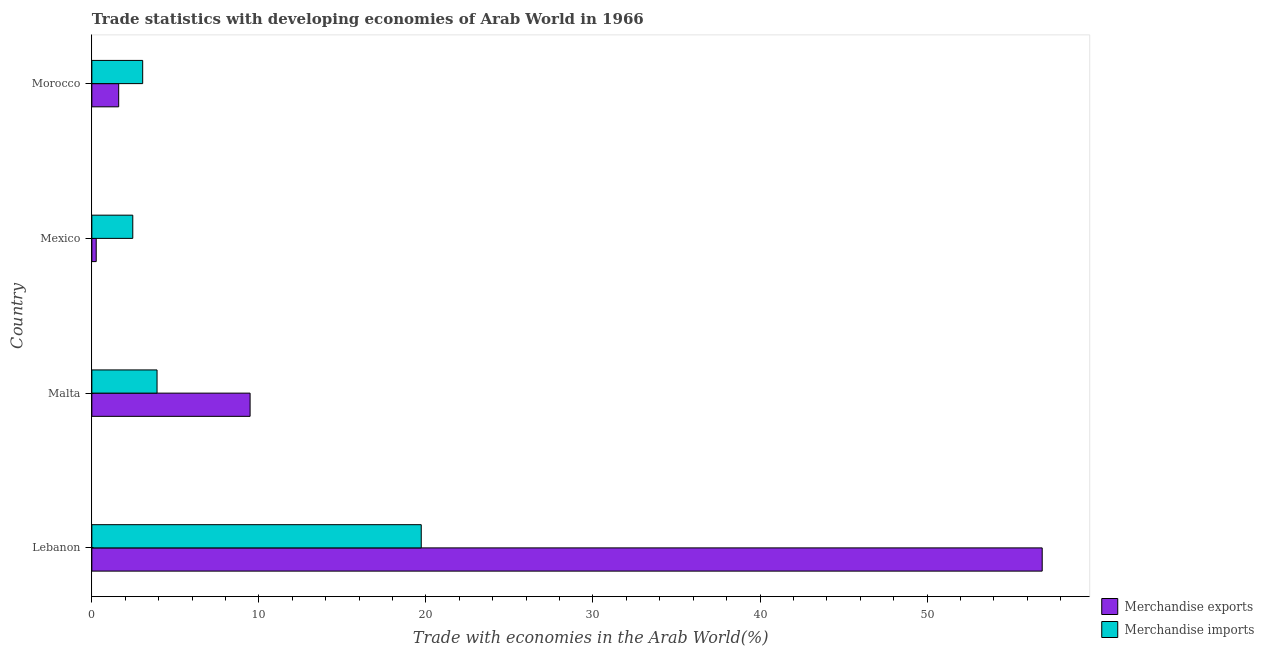How many different coloured bars are there?
Provide a succinct answer. 2. How many groups of bars are there?
Keep it short and to the point. 4. How many bars are there on the 3rd tick from the top?
Keep it short and to the point. 2. What is the label of the 4th group of bars from the top?
Keep it short and to the point. Lebanon. What is the merchandise exports in Lebanon?
Give a very brief answer. 56.89. Across all countries, what is the maximum merchandise exports?
Offer a very short reply. 56.89. Across all countries, what is the minimum merchandise exports?
Make the answer very short. 0.26. In which country was the merchandise exports maximum?
Give a very brief answer. Lebanon. In which country was the merchandise exports minimum?
Keep it short and to the point. Mexico. What is the total merchandise imports in the graph?
Your response must be concise. 29.12. What is the difference between the merchandise imports in Mexico and that in Morocco?
Your answer should be very brief. -0.59. What is the difference between the merchandise exports in Lebanon and the merchandise imports in Malta?
Keep it short and to the point. 52.99. What is the average merchandise imports per country?
Your response must be concise. 7.28. What is the difference between the merchandise imports and merchandise exports in Mexico?
Give a very brief answer. 2.19. What is the ratio of the merchandise imports in Lebanon to that in Mexico?
Offer a terse response. 8.05. Is the difference between the merchandise exports in Malta and Mexico greater than the difference between the merchandise imports in Malta and Mexico?
Ensure brevity in your answer.  Yes. What is the difference between the highest and the second highest merchandise exports?
Your answer should be very brief. 47.42. What is the difference between the highest and the lowest merchandise exports?
Offer a terse response. 56.63. In how many countries, is the merchandise exports greater than the average merchandise exports taken over all countries?
Your response must be concise. 1. Is the sum of the merchandise exports in Malta and Morocco greater than the maximum merchandise imports across all countries?
Provide a short and direct response. No. What does the 1st bar from the top in Malta represents?
Offer a very short reply. Merchandise imports. What is the difference between two consecutive major ticks on the X-axis?
Give a very brief answer. 10. Does the graph contain any zero values?
Provide a short and direct response. No. Does the graph contain grids?
Make the answer very short. No. How are the legend labels stacked?
Offer a very short reply. Vertical. What is the title of the graph?
Keep it short and to the point. Trade statistics with developing economies of Arab World in 1966. What is the label or title of the X-axis?
Provide a short and direct response. Trade with economies in the Arab World(%). What is the Trade with economies in the Arab World(%) in Merchandise exports in Lebanon?
Give a very brief answer. 56.89. What is the Trade with economies in the Arab World(%) in Merchandise imports in Lebanon?
Provide a succinct answer. 19.72. What is the Trade with economies in the Arab World(%) of Merchandise exports in Malta?
Your answer should be very brief. 9.47. What is the Trade with economies in the Arab World(%) of Merchandise imports in Malta?
Your answer should be compact. 3.9. What is the Trade with economies in the Arab World(%) in Merchandise exports in Mexico?
Keep it short and to the point. 0.26. What is the Trade with economies in the Arab World(%) in Merchandise imports in Mexico?
Provide a short and direct response. 2.45. What is the Trade with economies in the Arab World(%) of Merchandise exports in Morocco?
Offer a terse response. 1.61. What is the Trade with economies in the Arab World(%) in Merchandise imports in Morocco?
Your answer should be compact. 3.04. Across all countries, what is the maximum Trade with economies in the Arab World(%) of Merchandise exports?
Ensure brevity in your answer.  56.89. Across all countries, what is the maximum Trade with economies in the Arab World(%) of Merchandise imports?
Ensure brevity in your answer.  19.72. Across all countries, what is the minimum Trade with economies in the Arab World(%) in Merchandise exports?
Make the answer very short. 0.26. Across all countries, what is the minimum Trade with economies in the Arab World(%) of Merchandise imports?
Your answer should be very brief. 2.45. What is the total Trade with economies in the Arab World(%) in Merchandise exports in the graph?
Give a very brief answer. 68.23. What is the total Trade with economies in the Arab World(%) of Merchandise imports in the graph?
Offer a very short reply. 29.12. What is the difference between the Trade with economies in the Arab World(%) of Merchandise exports in Lebanon and that in Malta?
Offer a terse response. 47.42. What is the difference between the Trade with economies in the Arab World(%) of Merchandise imports in Lebanon and that in Malta?
Your answer should be compact. 15.82. What is the difference between the Trade with economies in the Arab World(%) in Merchandise exports in Lebanon and that in Mexico?
Your response must be concise. 56.63. What is the difference between the Trade with economies in the Arab World(%) in Merchandise imports in Lebanon and that in Mexico?
Your response must be concise. 17.27. What is the difference between the Trade with economies in the Arab World(%) in Merchandise exports in Lebanon and that in Morocco?
Offer a very short reply. 55.28. What is the difference between the Trade with economies in the Arab World(%) of Merchandise imports in Lebanon and that in Morocco?
Ensure brevity in your answer.  16.68. What is the difference between the Trade with economies in the Arab World(%) of Merchandise exports in Malta and that in Mexico?
Keep it short and to the point. 9.21. What is the difference between the Trade with economies in the Arab World(%) in Merchandise imports in Malta and that in Mexico?
Offer a terse response. 1.45. What is the difference between the Trade with economies in the Arab World(%) of Merchandise exports in Malta and that in Morocco?
Offer a very short reply. 7.87. What is the difference between the Trade with economies in the Arab World(%) in Merchandise imports in Malta and that in Morocco?
Offer a very short reply. 0.86. What is the difference between the Trade with economies in the Arab World(%) of Merchandise exports in Mexico and that in Morocco?
Your response must be concise. -1.35. What is the difference between the Trade with economies in the Arab World(%) of Merchandise imports in Mexico and that in Morocco?
Make the answer very short. -0.59. What is the difference between the Trade with economies in the Arab World(%) of Merchandise exports in Lebanon and the Trade with economies in the Arab World(%) of Merchandise imports in Malta?
Your answer should be compact. 52.99. What is the difference between the Trade with economies in the Arab World(%) in Merchandise exports in Lebanon and the Trade with economies in the Arab World(%) in Merchandise imports in Mexico?
Offer a very short reply. 54.44. What is the difference between the Trade with economies in the Arab World(%) in Merchandise exports in Lebanon and the Trade with economies in the Arab World(%) in Merchandise imports in Morocco?
Offer a terse response. 53.85. What is the difference between the Trade with economies in the Arab World(%) of Merchandise exports in Malta and the Trade with economies in the Arab World(%) of Merchandise imports in Mexico?
Provide a succinct answer. 7.02. What is the difference between the Trade with economies in the Arab World(%) of Merchandise exports in Malta and the Trade with economies in the Arab World(%) of Merchandise imports in Morocco?
Your response must be concise. 6.43. What is the difference between the Trade with economies in the Arab World(%) of Merchandise exports in Mexico and the Trade with economies in the Arab World(%) of Merchandise imports in Morocco?
Offer a terse response. -2.78. What is the average Trade with economies in the Arab World(%) in Merchandise exports per country?
Ensure brevity in your answer.  17.06. What is the average Trade with economies in the Arab World(%) in Merchandise imports per country?
Your answer should be very brief. 7.28. What is the difference between the Trade with economies in the Arab World(%) in Merchandise exports and Trade with economies in the Arab World(%) in Merchandise imports in Lebanon?
Your answer should be very brief. 37.17. What is the difference between the Trade with economies in the Arab World(%) in Merchandise exports and Trade with economies in the Arab World(%) in Merchandise imports in Malta?
Give a very brief answer. 5.57. What is the difference between the Trade with economies in the Arab World(%) of Merchandise exports and Trade with economies in the Arab World(%) of Merchandise imports in Mexico?
Give a very brief answer. -2.19. What is the difference between the Trade with economies in the Arab World(%) in Merchandise exports and Trade with economies in the Arab World(%) in Merchandise imports in Morocco?
Offer a very short reply. -1.44. What is the ratio of the Trade with economies in the Arab World(%) of Merchandise exports in Lebanon to that in Malta?
Your response must be concise. 6.01. What is the ratio of the Trade with economies in the Arab World(%) in Merchandise imports in Lebanon to that in Malta?
Make the answer very short. 5.05. What is the ratio of the Trade with economies in the Arab World(%) of Merchandise exports in Lebanon to that in Mexico?
Your response must be concise. 217.38. What is the ratio of the Trade with economies in the Arab World(%) of Merchandise imports in Lebanon to that in Mexico?
Make the answer very short. 8.05. What is the ratio of the Trade with economies in the Arab World(%) of Merchandise exports in Lebanon to that in Morocco?
Offer a very short reply. 35.4. What is the ratio of the Trade with economies in the Arab World(%) of Merchandise imports in Lebanon to that in Morocco?
Make the answer very short. 6.48. What is the ratio of the Trade with economies in the Arab World(%) in Merchandise exports in Malta to that in Mexico?
Your response must be concise. 36.2. What is the ratio of the Trade with economies in the Arab World(%) of Merchandise imports in Malta to that in Mexico?
Provide a short and direct response. 1.59. What is the ratio of the Trade with economies in the Arab World(%) of Merchandise exports in Malta to that in Morocco?
Give a very brief answer. 5.89. What is the ratio of the Trade with economies in the Arab World(%) in Merchandise imports in Malta to that in Morocco?
Offer a very short reply. 1.28. What is the ratio of the Trade with economies in the Arab World(%) in Merchandise exports in Mexico to that in Morocco?
Make the answer very short. 0.16. What is the ratio of the Trade with economies in the Arab World(%) in Merchandise imports in Mexico to that in Morocco?
Your answer should be very brief. 0.81. What is the difference between the highest and the second highest Trade with economies in the Arab World(%) of Merchandise exports?
Offer a terse response. 47.42. What is the difference between the highest and the second highest Trade with economies in the Arab World(%) of Merchandise imports?
Provide a short and direct response. 15.82. What is the difference between the highest and the lowest Trade with economies in the Arab World(%) in Merchandise exports?
Offer a very short reply. 56.63. What is the difference between the highest and the lowest Trade with economies in the Arab World(%) of Merchandise imports?
Keep it short and to the point. 17.27. 